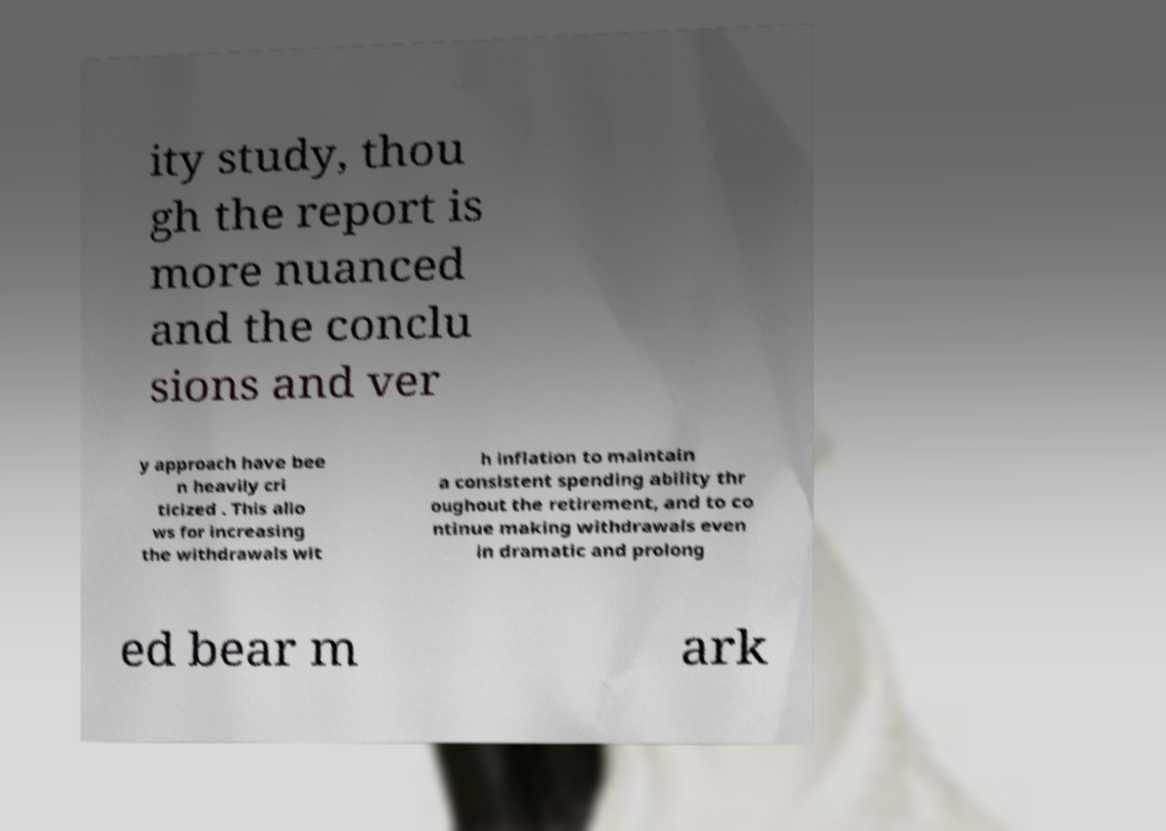Could you extract and type out the text from this image? ity study, thou gh the report is more nuanced and the conclu sions and ver y approach have bee n heavily cri ticized . This allo ws for increasing the withdrawals wit h inflation to maintain a consistent spending ability thr oughout the retirement, and to co ntinue making withdrawals even in dramatic and prolong ed bear m ark 